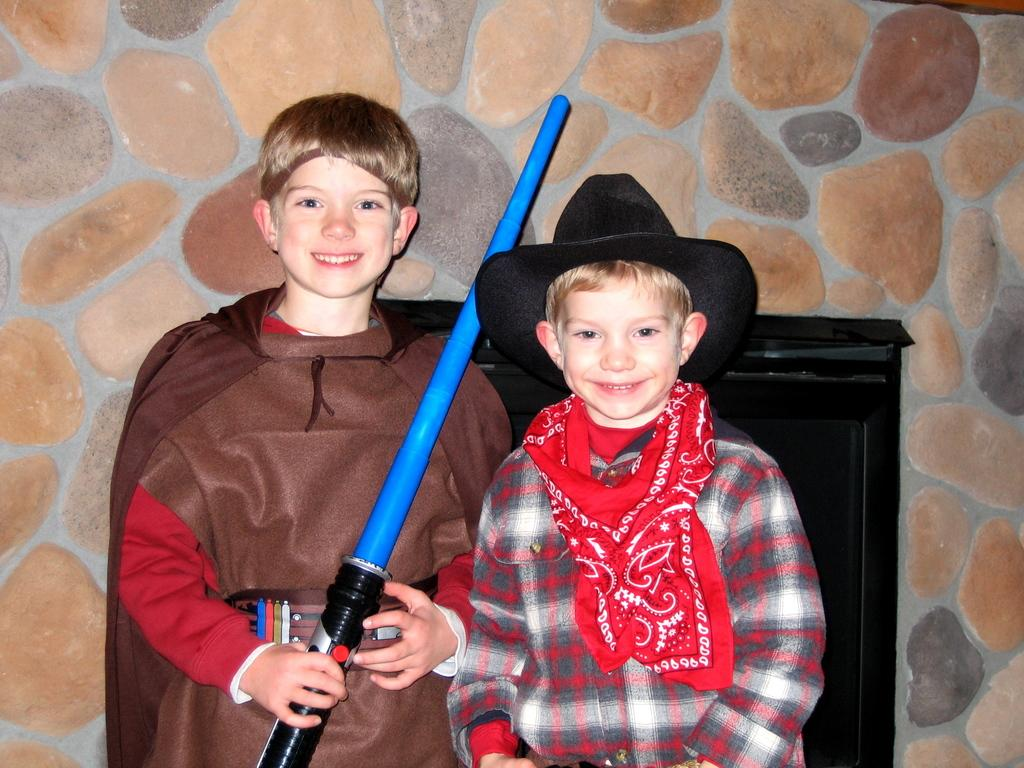What is the boy holding in the image? The boy is holding something in the image, but the specific object is not mentioned in the facts. What is the second boy wearing in the image? The second boy is wearing a hat and a scarf in the image. What can be seen in the background of the image? There is a wooden object and a wall in the background of the image. What type of joke is the boy telling in the image? There is no indication in the image that the boy is telling a joke, so it cannot be determined from the picture. 